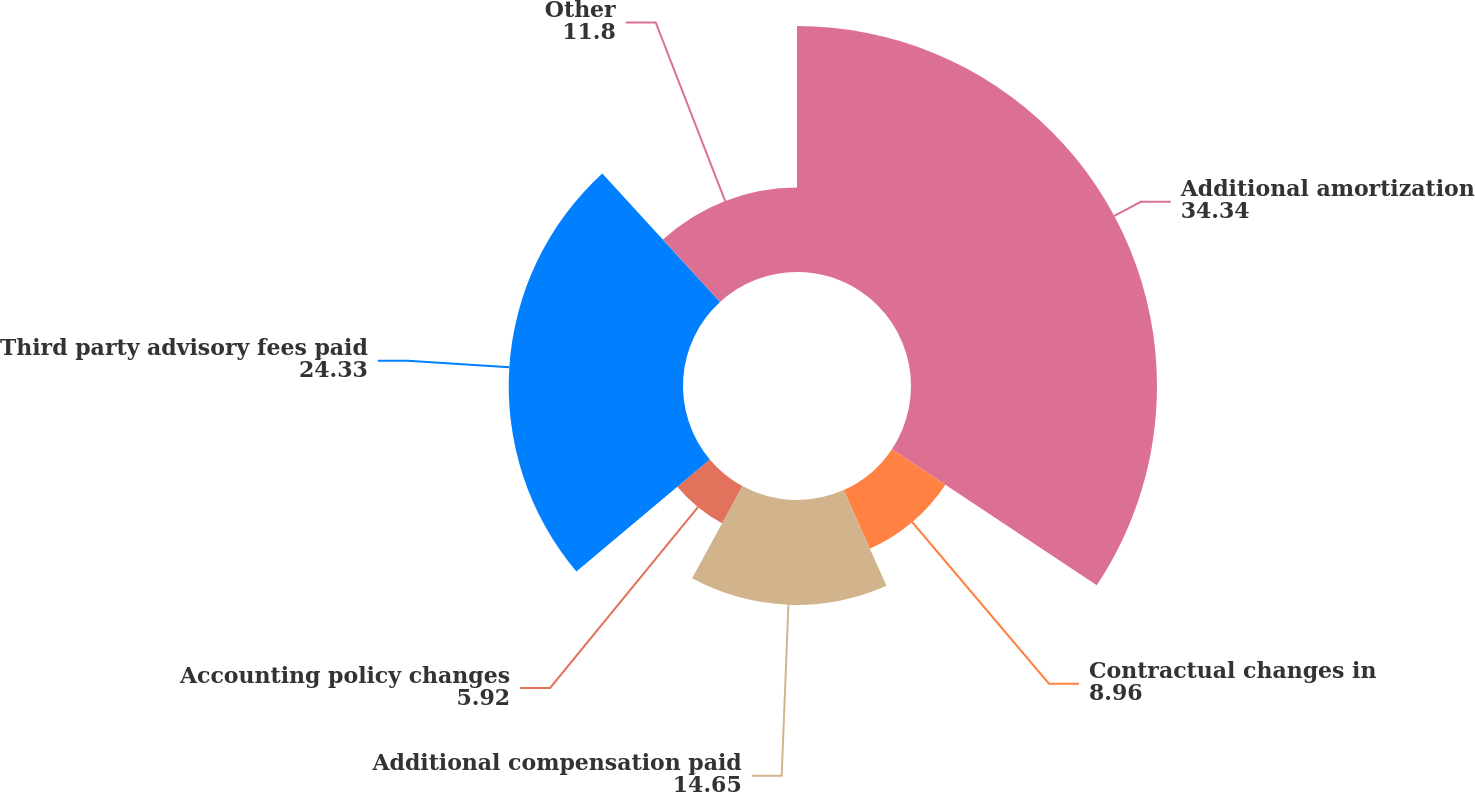Convert chart to OTSL. <chart><loc_0><loc_0><loc_500><loc_500><pie_chart><fcel>Additional amortization<fcel>Contractual changes in<fcel>Additional compensation paid<fcel>Accounting policy changes<fcel>Third party advisory fees paid<fcel>Other<nl><fcel>34.34%<fcel>8.96%<fcel>14.65%<fcel>5.92%<fcel>24.33%<fcel>11.8%<nl></chart> 